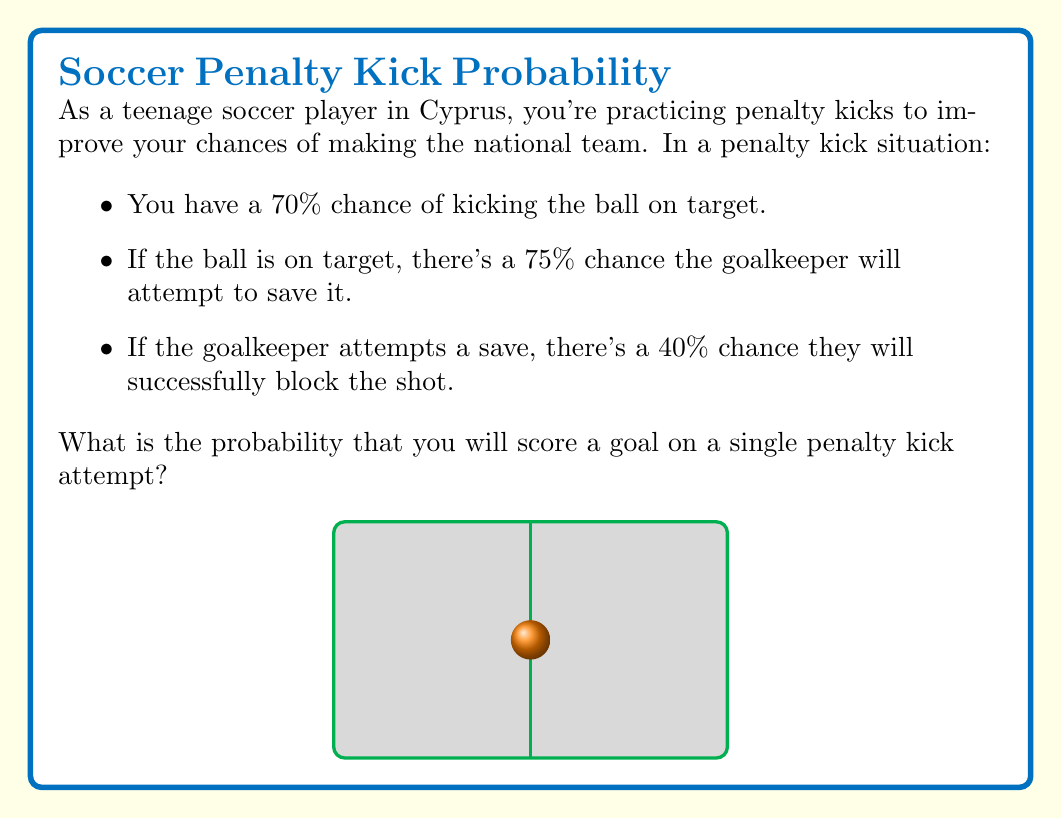Can you solve this math problem? Let's break this down step-by-step:

1) First, we need to identify the probability of scoring a goal. This can happen in two ways:
   a) The ball is on target and the goalkeeper doesn't attempt to save it.
   b) The ball is on target, the goalkeeper attempts to save it, but fails.

2) Let's calculate each probability:

   a) P(on target) × P(goalkeeper doesn't attempt save)
      $0.70 × (1 - 0.75) = 0.70 × 0.25 = 0.175$

   b) P(on target) × P(goalkeeper attempts save) × P(goalkeeper fails to save)
      $0.70 × 0.75 × (1 - 0.40) = 0.70 × 0.75 × 0.60 = 0.315$

3) The total probability of scoring is the sum of these two probabilities:

   $P(\text{scoring}) = 0.175 + 0.315 = 0.49$

4) We can also verify this by calculating the probability of not scoring:

   P(not scoring) = P(off target) + P(on target and saved)
                  = $0.30 + (0.70 × 0.75 × 0.40) = 0.30 + 0.21 = 0.51$

   $P(\text{scoring}) = 1 - P(\text{not scoring}) = 1 - 0.51 = 0.49$

Therefore, the probability of scoring a goal on a single penalty kick attempt is 0.49 or 49%.
Answer: 0.49 